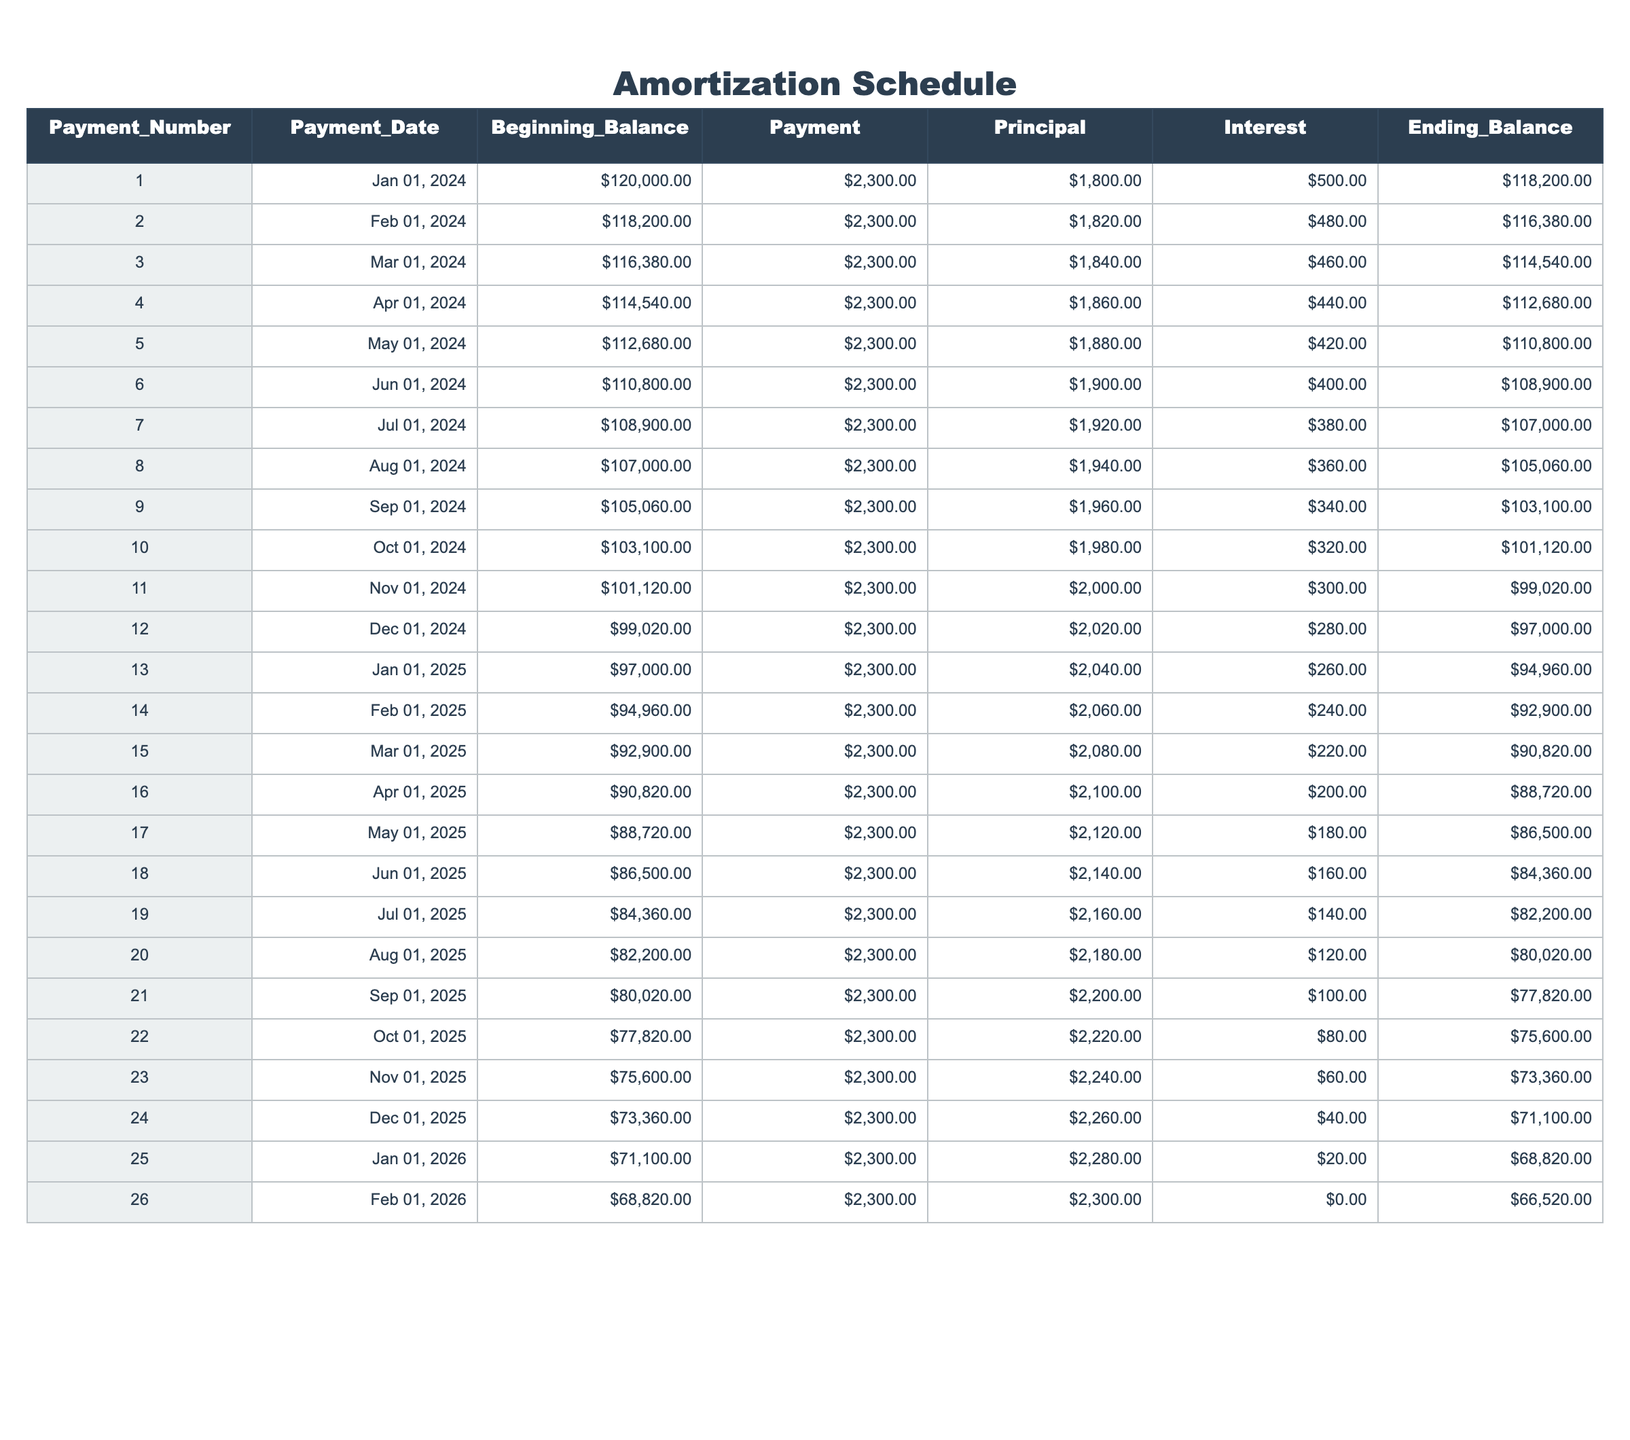What is the payment amount for the first month? The first month's payment is listed in the table under the "Payment" column for Payment Number 1, which is $2,300.
Answer: $2,300 How much principal is paid off in the 10th payment? To find the principal paid in the 10th payment, we can look at the "Principal" column under Payment Number 10, which shows $1,980.
Answer: $1,980 Is the interest paid in the 15th payment higher than the interest paid in the 5th payment? For the 15th payment, the interest is $220, and for the 5th payment, it is $420. Since $220 is less than $420, the interest in the 15th payment is not higher.
Answer: No What is the total amount of interest paid from the 1st to the 12th payment? To find the total interest paid, we sum the "Interest" column from Payment Numbers 1 through 12. This results in: 500 + 480 + 460 + 440 + 420 + 400 + 380 + 360 + 340 + 320 + 300 + 280 = 4,400.
Answer: $4,400 What is the average principal payment over the first 6 months? The principal payments for the first 6 months are: 1,800, 1,820, 1,840, 1,860, 1,880, and 1,900. The total is: 1,800 + 1,820 + 1,840 + 1,860 + 1,880 + 1,900 = 10,100. The average is 10,100 / 6 = 1,683.33.
Answer: $1,683.33 